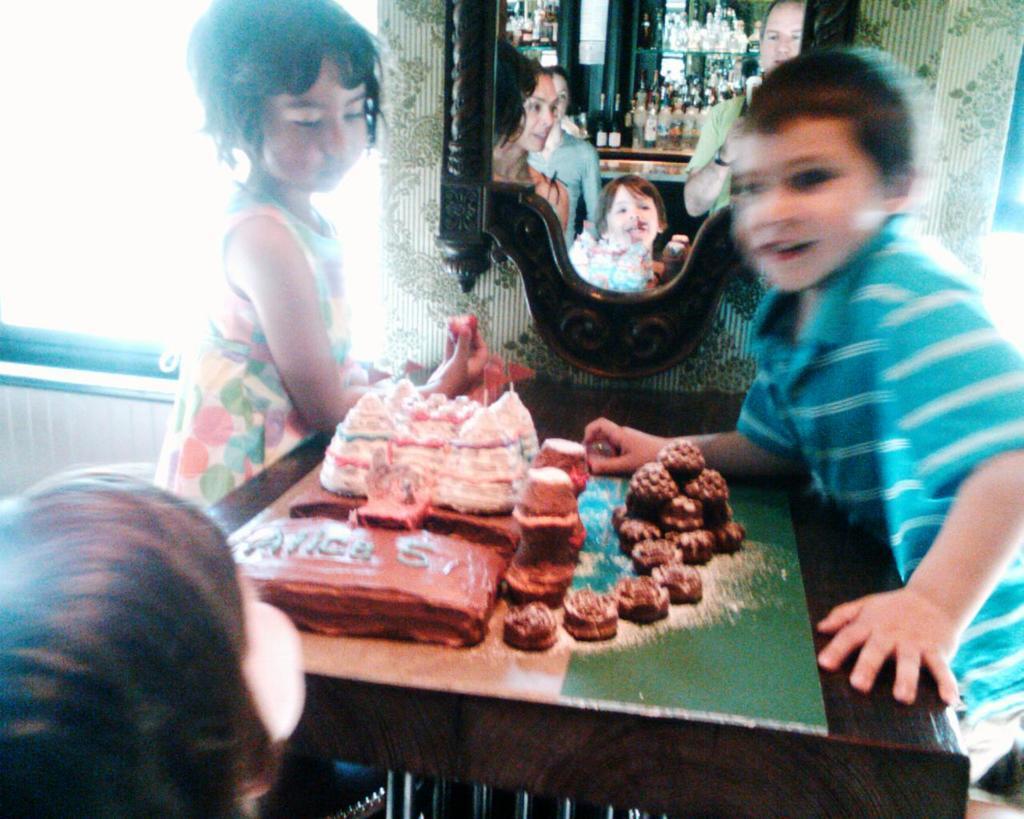Could you give a brief overview of what you see in this image? This picture is taken inside the room. In this image, on the right side, we can see a boy standing in front of a table. On the table, we can also see some food items. In the left corner, we can also see the head of a kid. On the left side, we can see a girl standing in front of the table. In the background, we can see a mirror. In the mirror, we can see a group of people and a few bottles on the table. On the left side, we can also see white color and a metal rod. 